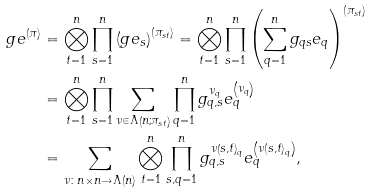<formula> <loc_0><loc_0><loc_500><loc_500>g e ^ { \left ( \pi \right ) } & = \bigotimes _ { t = 1 } ^ { n } \prod _ { s = 1 } ^ { n } \left ( g e _ { s } \right ) ^ { \left ( \pi _ { s t } \right ) } = \bigotimes _ { t = 1 } ^ { n } \prod _ { s = 1 } ^ { n } \left ( \sum _ { q = 1 } ^ { n } g _ { q s } e _ { q } \right ) ^ { \left ( \pi _ { s t } \right ) } \\ & = \bigotimes _ { t = 1 } ^ { n } \prod _ { s = 1 } ^ { n } \sum _ { \nu \in \Lambda \left ( n ; \pi _ { s t } \right ) } \prod _ { q = 1 } ^ { n } g _ { q , s } ^ { \nu _ { q } } e _ { q } ^ { \left ( \nu _ { q } \right ) } \\ & = \sum _ { \nu \colon n \times n \to \Lambda \left ( n \right ) } \bigotimes _ { t = 1 } ^ { n } \prod _ { s , q = 1 } ^ { n } g ^ { \nu \left ( s , t \right ) _ { q } } _ { q , s } e _ { q } ^ { \left ( \nu \left ( s , t \right ) _ { q } \right ) } ,</formula> 